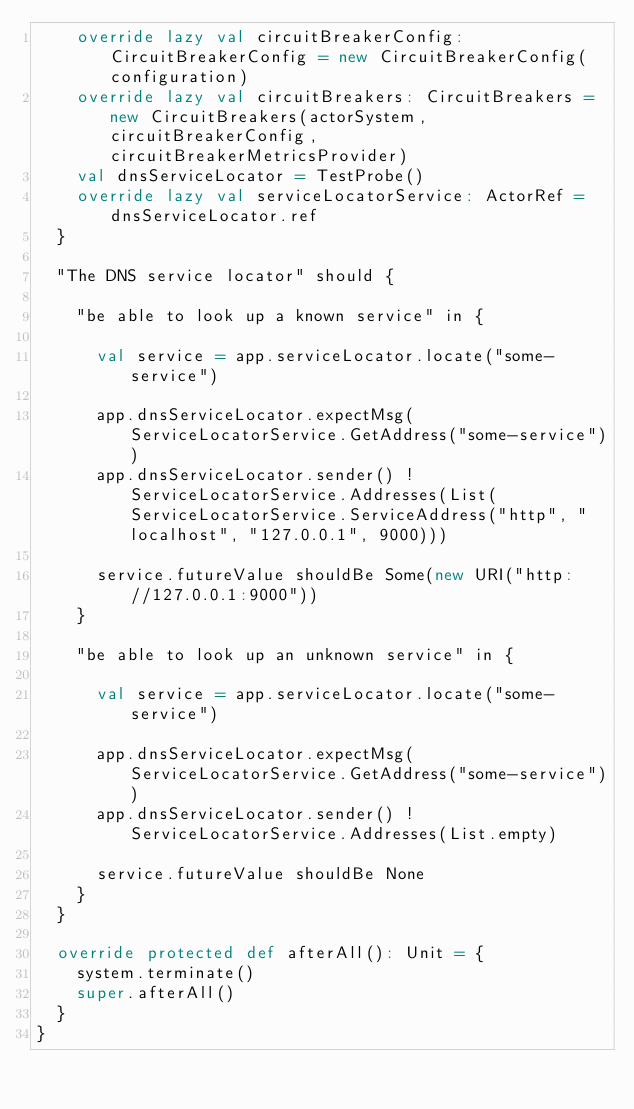Convert code to text. <code><loc_0><loc_0><loc_500><loc_500><_Scala_>    override lazy val circuitBreakerConfig: CircuitBreakerConfig = new CircuitBreakerConfig(configuration)
    override lazy val circuitBreakers: CircuitBreakers = new CircuitBreakers(actorSystem, circuitBreakerConfig, circuitBreakerMetricsProvider)
    val dnsServiceLocator = TestProbe()
    override lazy val serviceLocatorService: ActorRef = dnsServiceLocator.ref
  }

  "The DNS service locator" should {

    "be able to look up a known service" in {

      val service = app.serviceLocator.locate("some-service")

      app.dnsServiceLocator.expectMsg(ServiceLocatorService.GetAddress("some-service"))
      app.dnsServiceLocator.sender() ! ServiceLocatorService.Addresses(List(ServiceLocatorService.ServiceAddress("http", "localhost", "127.0.0.1", 9000)))

      service.futureValue shouldBe Some(new URI("http://127.0.0.1:9000"))
    }

    "be able to look up an unknown service" in {

      val service = app.serviceLocator.locate("some-service")

      app.dnsServiceLocator.expectMsg(ServiceLocatorService.GetAddress("some-service"))
      app.dnsServiceLocator.sender() ! ServiceLocatorService.Addresses(List.empty)

      service.futureValue shouldBe None
    }
  }

  override protected def afterAll(): Unit = {
    system.terminate()
    super.afterAll()
  }
}
</code> 